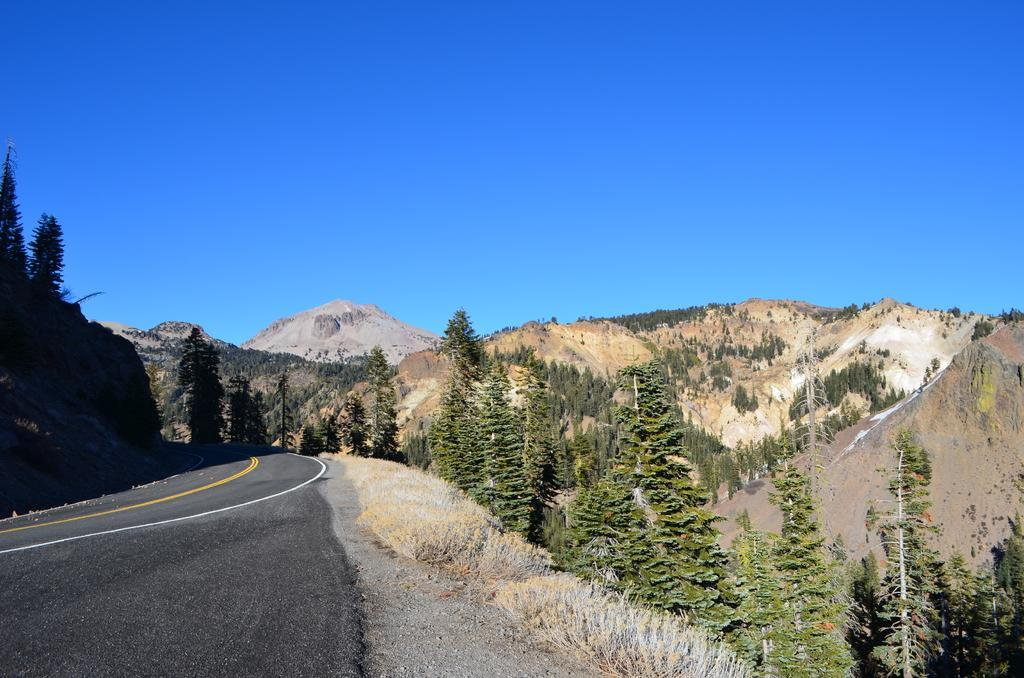What type of landscape can be seen in the image? There are hills in the image. What other natural elements are present in the image? There are trees in the image. Is there any man-made structure visible in the image? Yes, there is a road in the image. What is the color of the sky in the image? The sky is blue in the image. What type of disease is affecting the trees in the image? There is no indication of any disease affecting the trees in the image; they appear healthy. What type of cabbage can be seen growing on the hills in the image? There are no cabbages present in the image; it features hills, trees, a road, and a blue sky. 